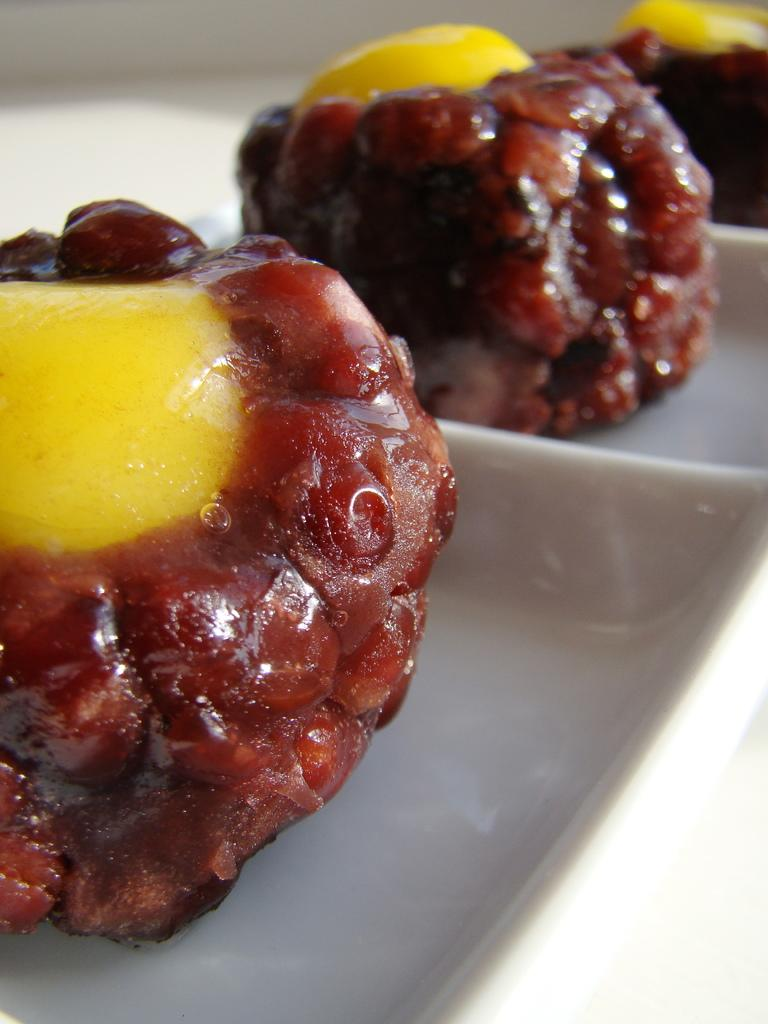What is present on the plate in the image? There are food items in a plate in the image. How many ants can be seen carrying food items from the plate in the image? There are no ants present in the image, and therefore no such activity can be observed. 